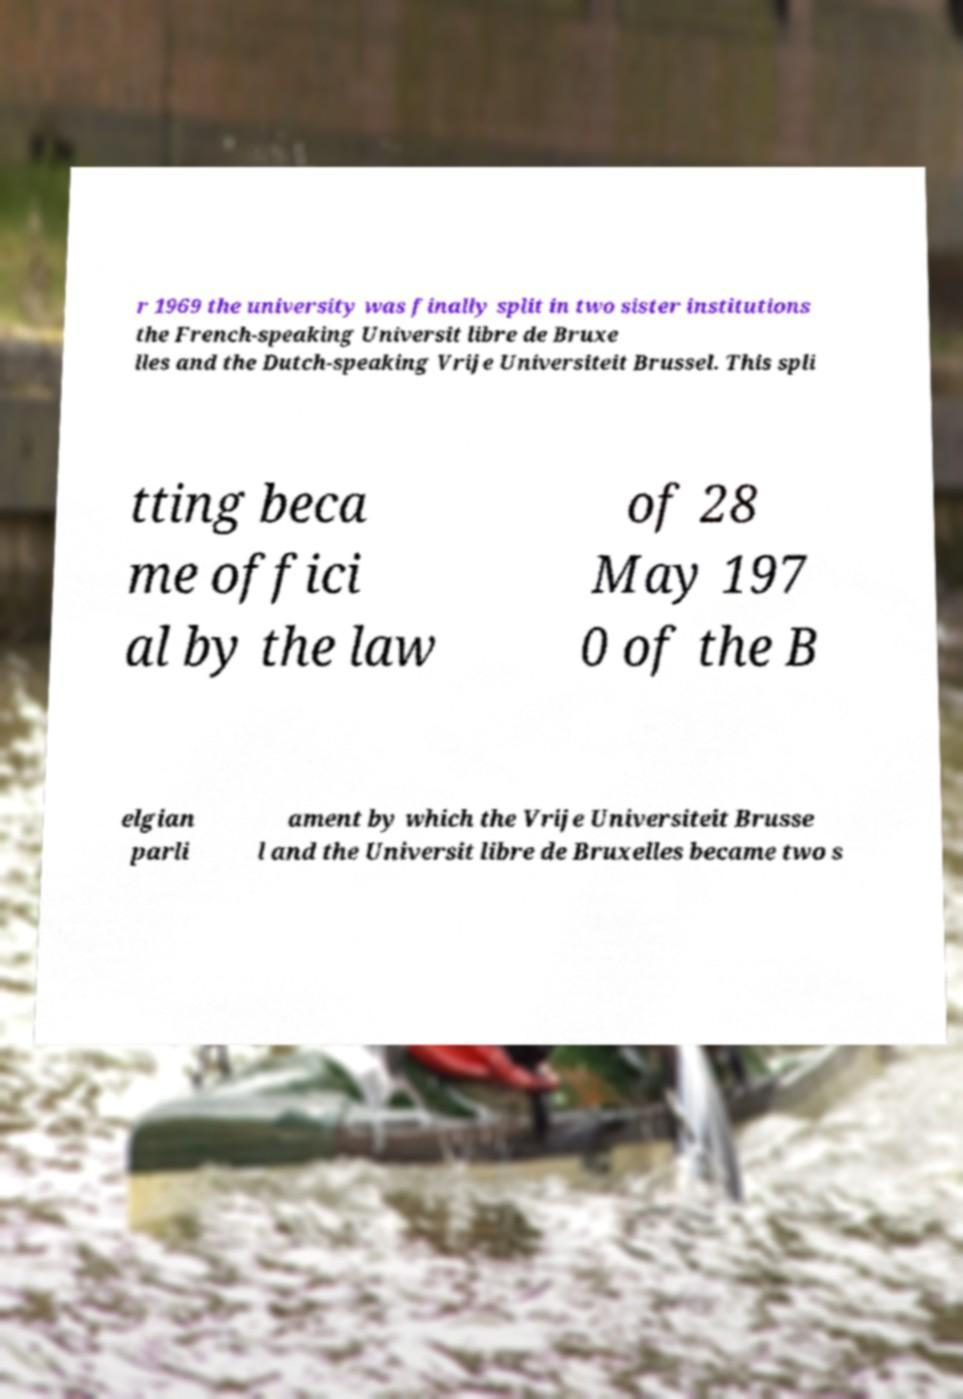Please read and relay the text visible in this image. What does it say? r 1969 the university was finally split in two sister institutions the French-speaking Universit libre de Bruxe lles and the Dutch-speaking Vrije Universiteit Brussel. This spli tting beca me offici al by the law of 28 May 197 0 of the B elgian parli ament by which the Vrije Universiteit Brusse l and the Universit libre de Bruxelles became two s 